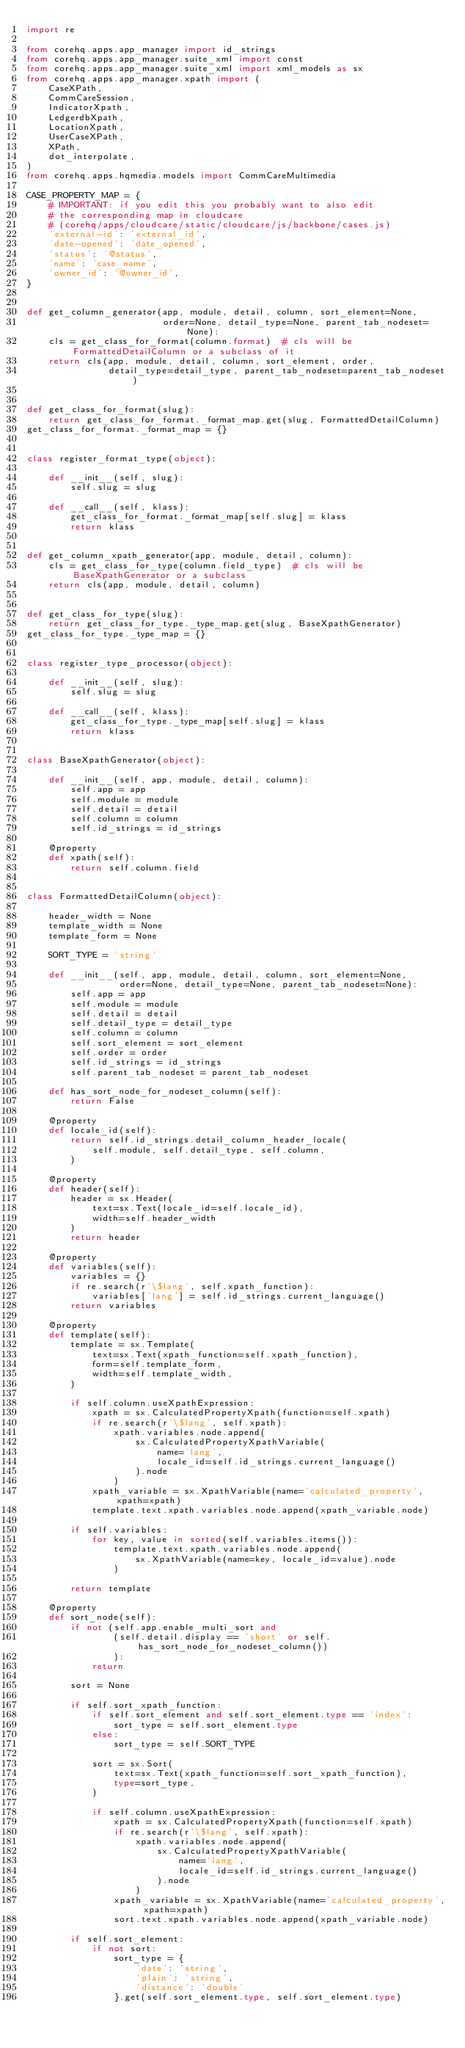<code> <loc_0><loc_0><loc_500><loc_500><_Python_>import re

from corehq.apps.app_manager import id_strings
from corehq.apps.app_manager.suite_xml import const
from corehq.apps.app_manager.suite_xml import xml_models as sx
from corehq.apps.app_manager.xpath import (
    CaseXPath,
    CommCareSession,
    IndicatorXpath,
    LedgerdbXpath,
    LocationXpath,
    UserCaseXPath,
    XPath,
    dot_interpolate,
)
from corehq.apps.hqmedia.models import CommCareMultimedia

CASE_PROPERTY_MAP = {
    # IMPORTANT: if you edit this you probably want to also edit
    # the corresponding map in cloudcare
    # (corehq/apps/cloudcare/static/cloudcare/js/backbone/cases.js)
    'external-id': 'external_id',
    'date-opened': 'date_opened',
    'status': '@status',
    'name': 'case_name',
    'owner_id': '@owner_id',
}


def get_column_generator(app, module, detail, column, sort_element=None,
                         order=None, detail_type=None, parent_tab_nodeset=None):
    cls = get_class_for_format(column.format)  # cls will be FormattedDetailColumn or a subclass of it
    return cls(app, module, detail, column, sort_element, order,
               detail_type=detail_type, parent_tab_nodeset=parent_tab_nodeset)


def get_class_for_format(slug):
    return get_class_for_format._format_map.get(slug, FormattedDetailColumn)
get_class_for_format._format_map = {}


class register_format_type(object):

    def __init__(self, slug):
        self.slug = slug

    def __call__(self, klass):
        get_class_for_format._format_map[self.slug] = klass
        return klass


def get_column_xpath_generator(app, module, detail, column):
    cls = get_class_for_type(column.field_type)  # cls will be BaseXpathGenerator or a subclass
    return cls(app, module, detail, column)


def get_class_for_type(slug):
    return get_class_for_type._type_map.get(slug, BaseXpathGenerator)
get_class_for_type._type_map = {}


class register_type_processor(object):

    def __init__(self, slug):
        self.slug = slug

    def __call__(self, klass):
        get_class_for_type._type_map[self.slug] = klass
        return klass


class BaseXpathGenerator(object):

    def __init__(self, app, module, detail, column):
        self.app = app
        self.module = module
        self.detail = detail
        self.column = column
        self.id_strings = id_strings

    @property
    def xpath(self):
        return self.column.field


class FormattedDetailColumn(object):

    header_width = None
    template_width = None
    template_form = None

    SORT_TYPE = 'string'

    def __init__(self, app, module, detail, column, sort_element=None,
                 order=None, detail_type=None, parent_tab_nodeset=None):
        self.app = app
        self.module = module
        self.detail = detail
        self.detail_type = detail_type
        self.column = column
        self.sort_element = sort_element
        self.order = order
        self.id_strings = id_strings
        self.parent_tab_nodeset = parent_tab_nodeset

    def has_sort_node_for_nodeset_column(self):
        return False

    @property
    def locale_id(self):
        return self.id_strings.detail_column_header_locale(
            self.module, self.detail_type, self.column,
        )

    @property
    def header(self):
        header = sx.Header(
            text=sx.Text(locale_id=self.locale_id),
            width=self.header_width
        )
        return header

    @property
    def variables(self):
        variables = {}
        if re.search(r'\$lang', self.xpath_function):
            variables['lang'] = self.id_strings.current_language()
        return variables

    @property
    def template(self):
        template = sx.Template(
            text=sx.Text(xpath_function=self.xpath_function),
            form=self.template_form,
            width=self.template_width,
        )

        if self.column.useXpathExpression:
            xpath = sx.CalculatedPropertyXpath(function=self.xpath)
            if re.search(r'\$lang', self.xpath):
                xpath.variables.node.append(
                    sx.CalculatedPropertyXpathVariable(
                        name='lang',
                        locale_id=self.id_strings.current_language()
                    ).node
                )
            xpath_variable = sx.XpathVariable(name='calculated_property', xpath=xpath)
            template.text.xpath.variables.node.append(xpath_variable.node)

        if self.variables:
            for key, value in sorted(self.variables.items()):
                template.text.xpath.variables.node.append(
                    sx.XpathVariable(name=key, locale_id=value).node
                )

        return template

    @property
    def sort_node(self):
        if not (self.app.enable_multi_sort and
                (self.detail.display == 'short' or self.has_sort_node_for_nodeset_column())
                ):
            return

        sort = None

        if self.sort_xpath_function:
            if self.sort_element and self.sort_element.type == 'index':
                sort_type = self.sort_element.type
            else:
                sort_type = self.SORT_TYPE

            sort = sx.Sort(
                text=sx.Text(xpath_function=self.sort_xpath_function),
                type=sort_type,
            )

            if self.column.useXpathExpression:
                xpath = sx.CalculatedPropertyXpath(function=self.xpath)
                if re.search(r'\$lang', self.xpath):
                    xpath.variables.node.append(
                        sx.CalculatedPropertyXpathVariable(
                            name='lang',
                            locale_id=self.id_strings.current_language()
                        ).node
                    )
                xpath_variable = sx.XpathVariable(name='calculated_property', xpath=xpath)
                sort.text.xpath.variables.node.append(xpath_variable.node)

        if self.sort_element:
            if not sort:
                sort_type = {
                    'date': 'string',
                    'plain': 'string',
                    'distance': 'double'
                }.get(self.sort_element.type, self.sort_element.type)
</code> 